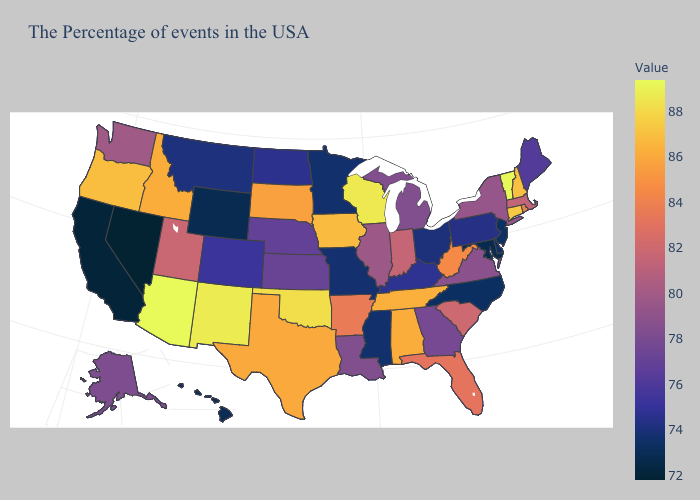Does Maryland have the lowest value in the South?
Quick response, please. Yes. Does Florida have the highest value in the South?
Be succinct. No. Among the states that border Florida , does Alabama have the highest value?
Short answer required. Yes. Among the states that border Missouri , does Oklahoma have the highest value?
Write a very short answer. Yes. Does Texas have the lowest value in the USA?
Keep it brief. No. Among the states that border Vermont , which have the lowest value?
Keep it brief. New York. Among the states that border Mississippi , which have the lowest value?
Concise answer only. Louisiana. Which states hav the highest value in the Northeast?
Be succinct. Vermont. 